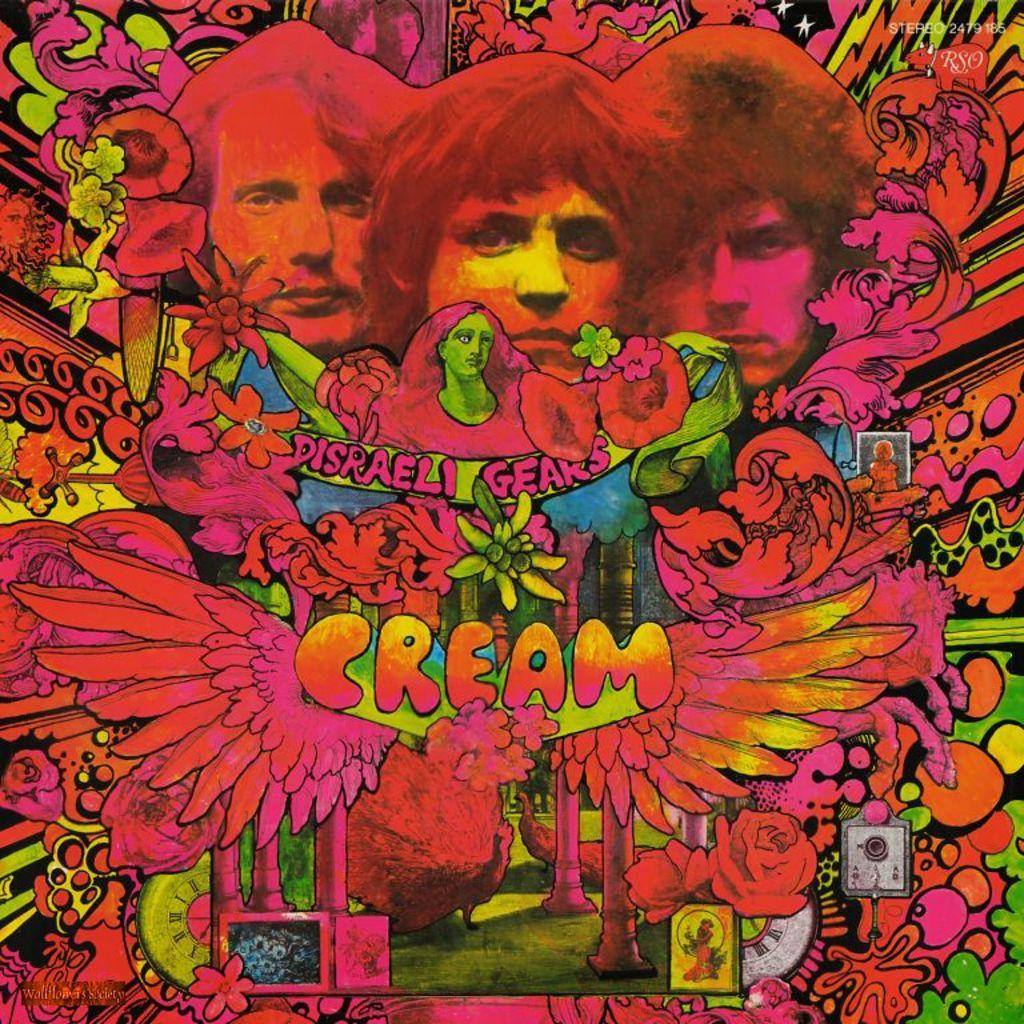<image>
Share a concise interpretation of the image provided. A bright neon colored sign that says Disreali Gears Cream. 